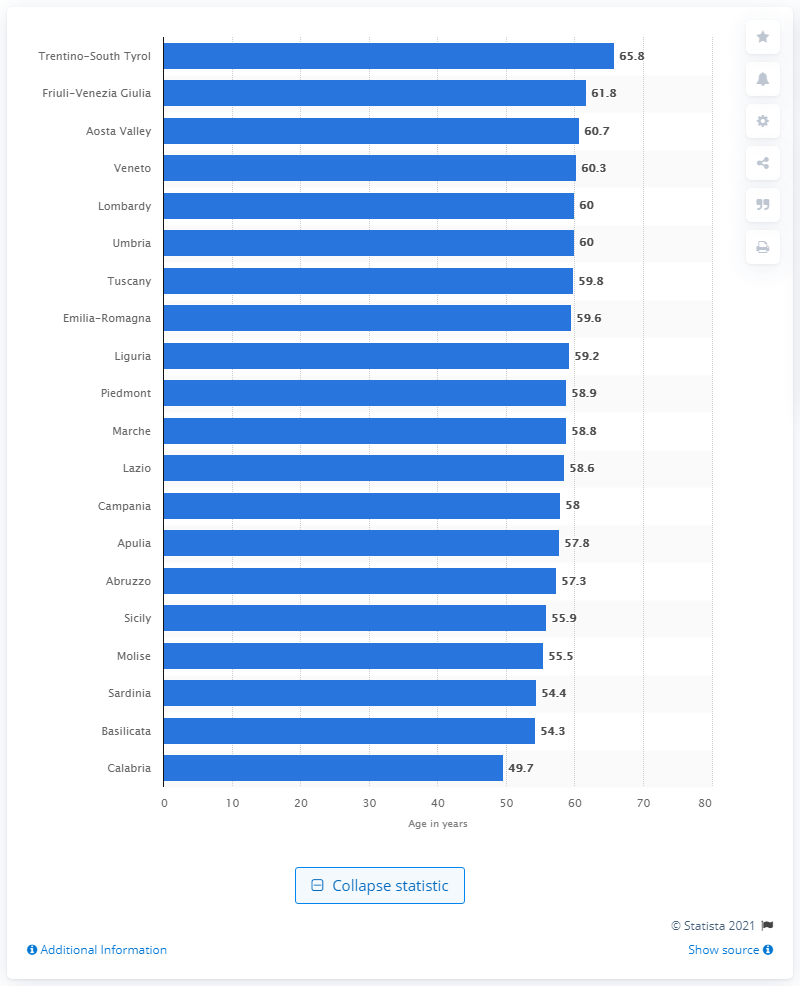Draw attention to some important aspects in this diagram. In 2019, the healthy life expectancy in Trentino-South Tyrol was 65.8 years. 